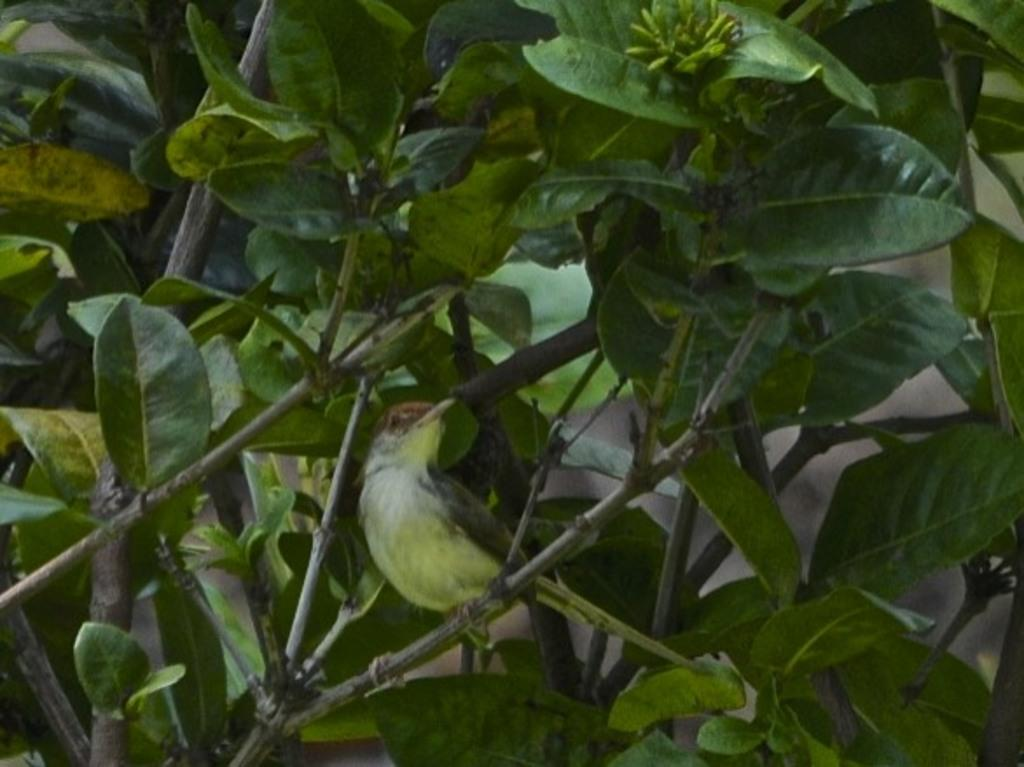What type of animal is in the image? There is a bird in the image. Where is the bird located in the image? The bird is on a branch. What type of vegetation is present in the image? There are leaves and branches in the image. Can you see the bird falling from the branch in the image? No, the bird is not falling from the branch in the image; it is perched on the branch. Is the bird acting as a spy in the image? There is no indication in the image that the bird is acting as a spy. 